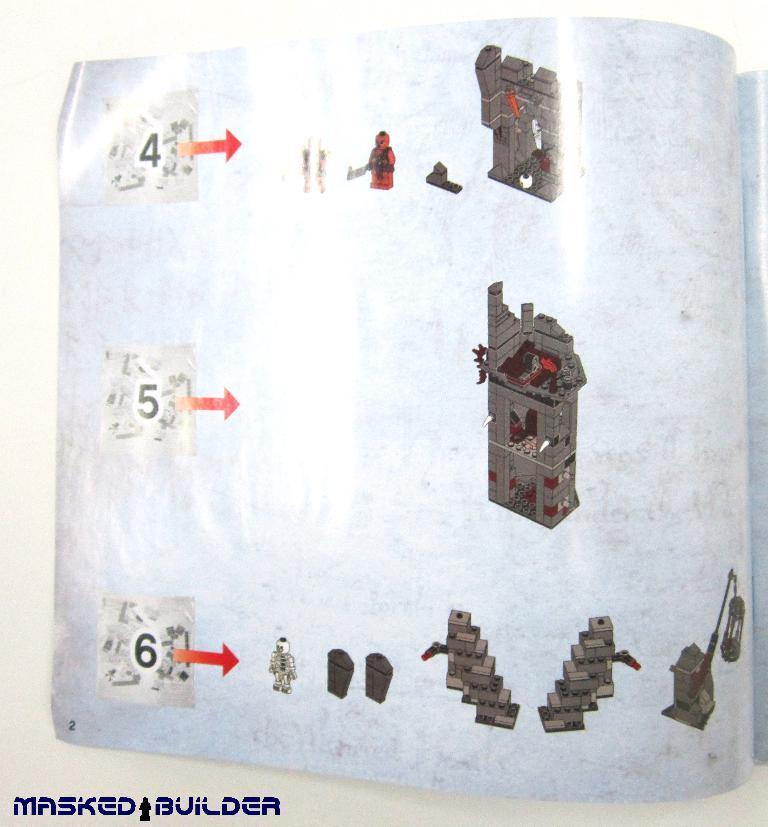In one or two sentences, can you explain what this image depicts? In this picture we can see a book on the surface with images, arrow signs and numbers on it. 